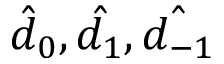<formula> <loc_0><loc_0><loc_500><loc_500>\hat { d } _ { 0 } , \hat { d _ { 1 } } , \hat { d _ { - 1 } }</formula> 